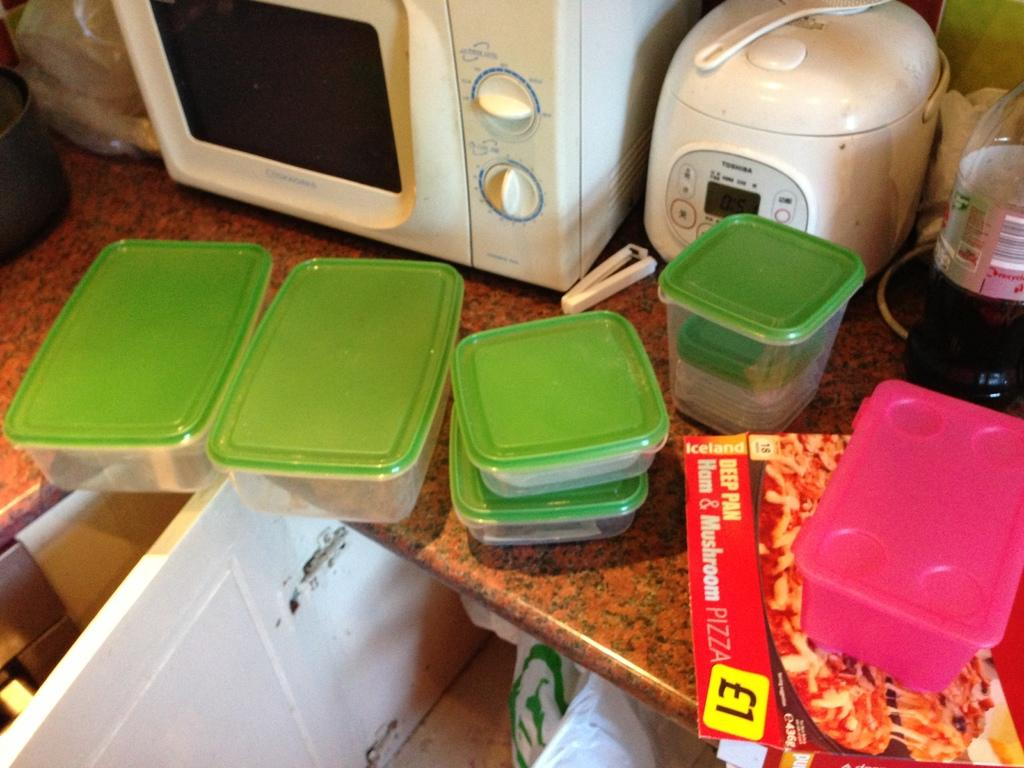What objects are located in the middle of the image? There are multiple boxes in the middle of the image. What can be seen at the top of the image? There is an oven at the top of the image. What is on the right side of the image? There is a bottle on the right side of the image. What type of underwear is visible in the image? There is no underwear present in the image. Can you read the letter that is being delivered in the image? There is no letter or delivery in the image. 